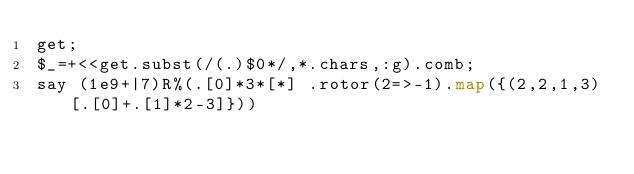<code> <loc_0><loc_0><loc_500><loc_500><_Perl_>get;
$_=+<<get.subst(/(.)$0*/,*.chars,:g).comb;
say (1e9+|7)R%(.[0]*3*[*] .rotor(2=>-1).map({(2,2,1,3)[.[0]+.[1]*2-3]}))</code> 